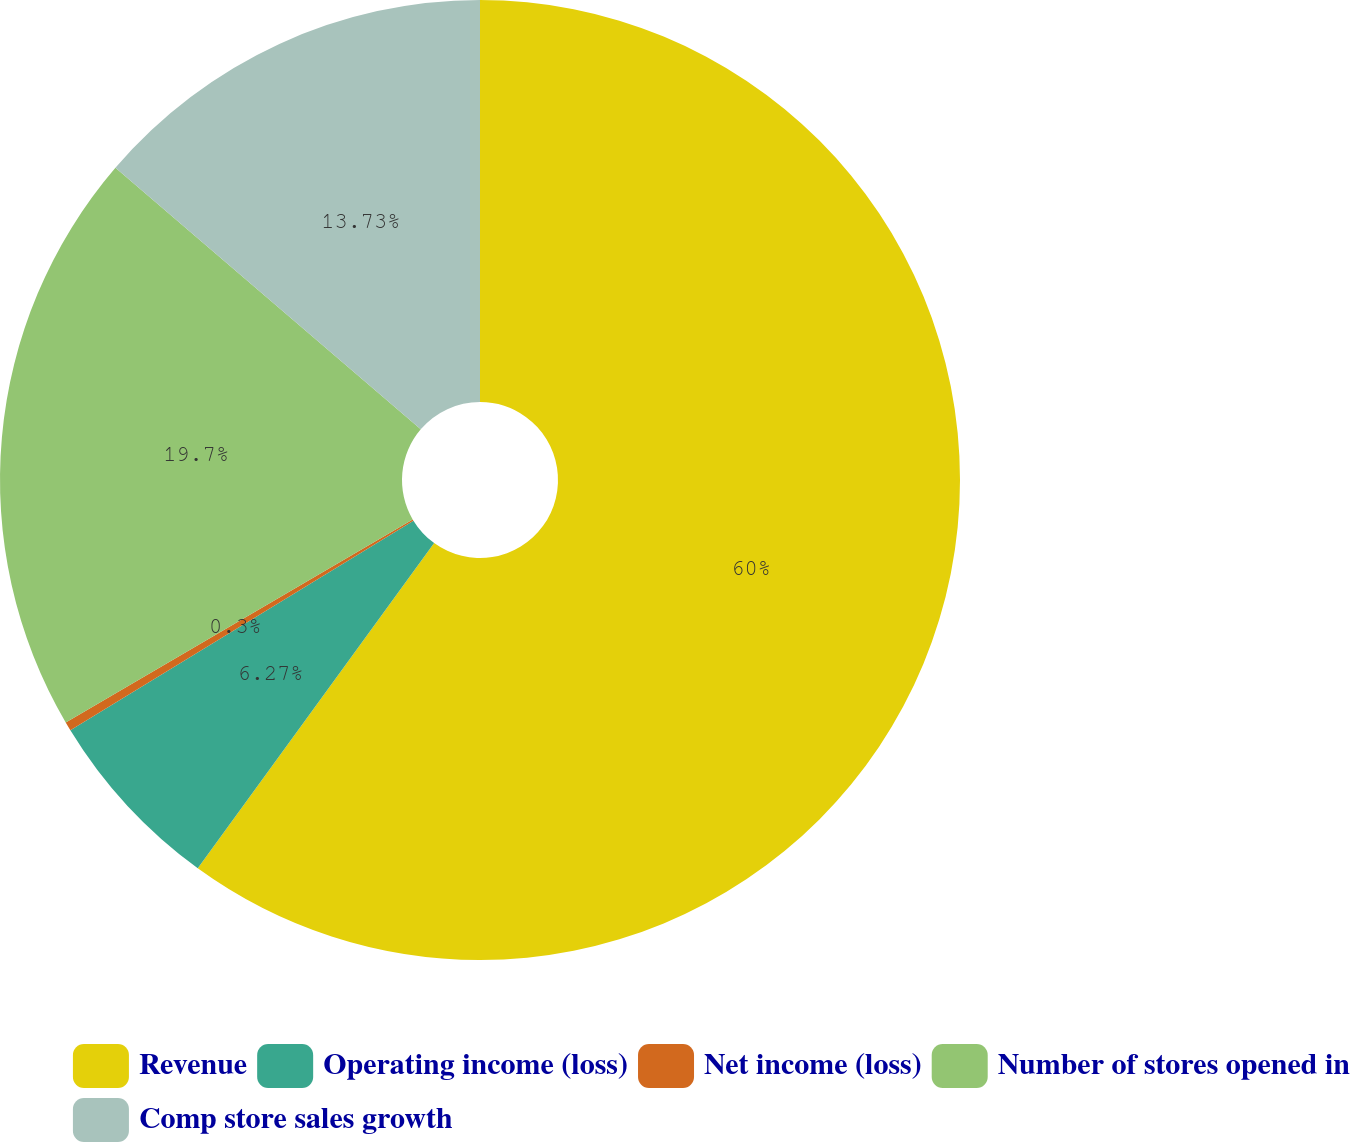<chart> <loc_0><loc_0><loc_500><loc_500><pie_chart><fcel>Revenue<fcel>Operating income (loss)<fcel>Net income (loss)<fcel>Number of stores opened in<fcel>Comp store sales growth<nl><fcel>60.01%<fcel>6.27%<fcel>0.3%<fcel>19.7%<fcel>13.73%<nl></chart> 